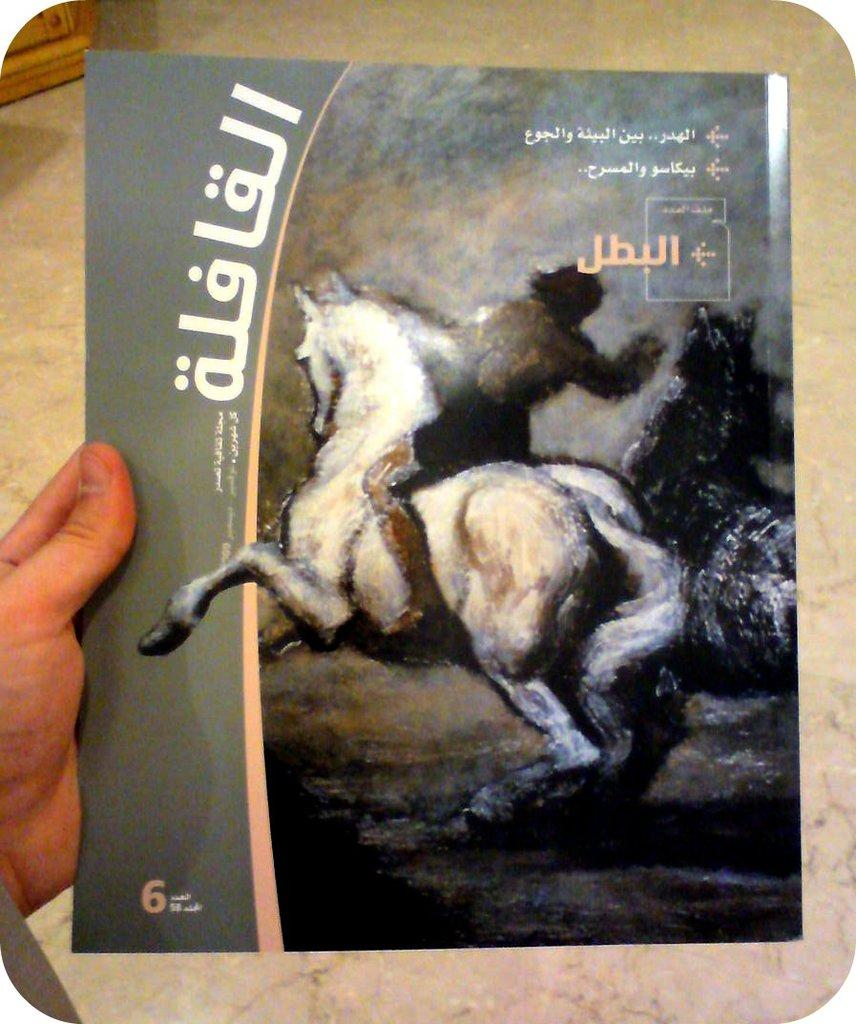Provide a one-sentence caption for the provided image. Book with a horse on it and number 6 from another country. 